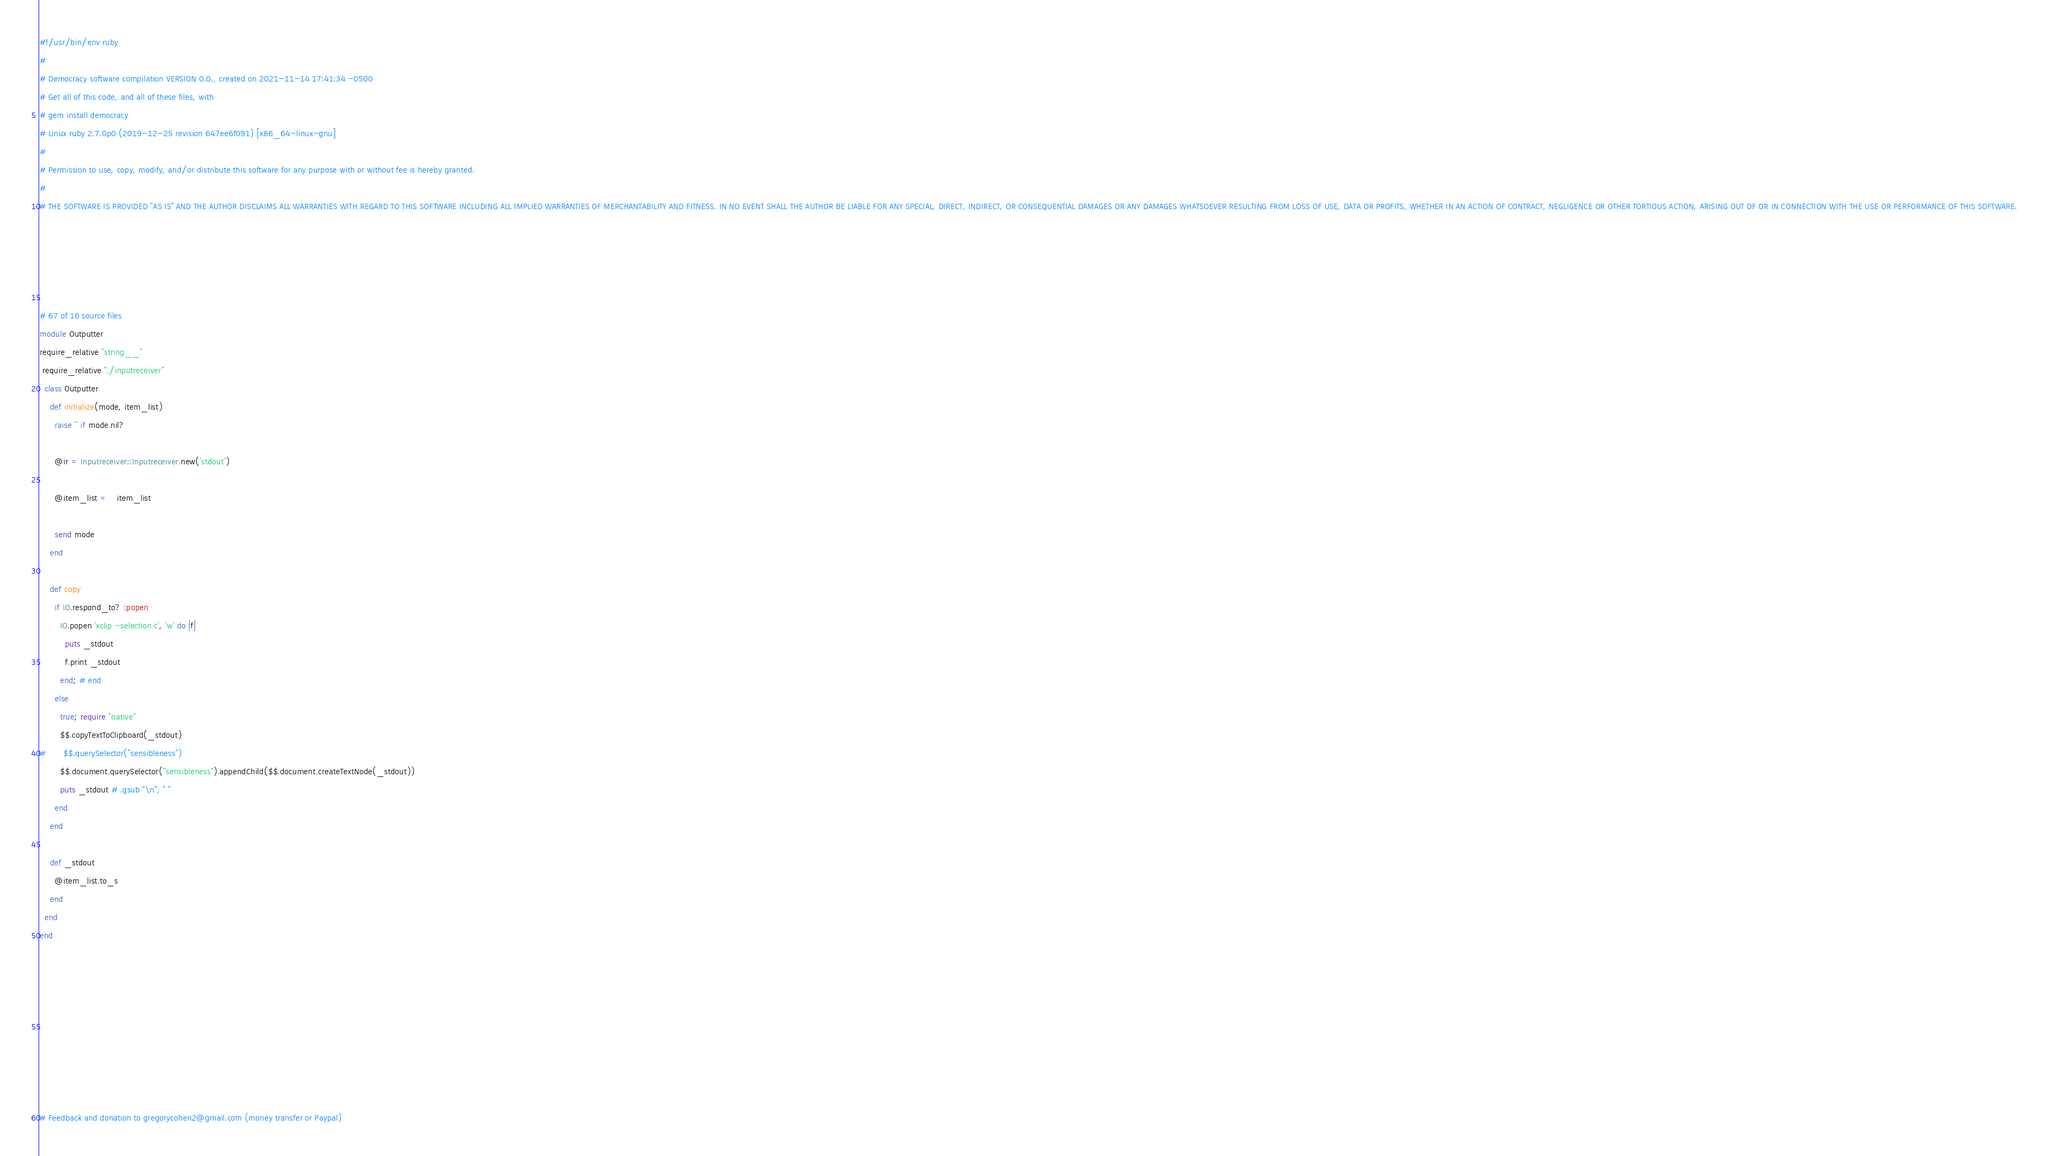<code> <loc_0><loc_0><loc_500><loc_500><_Ruby_>#!/usr/bin/env ruby
#
# Democracy software compilation VERSION 0.0., created on 2021-11-14 17:41:34 -0500
# Get all of this code, and all of these files, with
# gem install democracy
# Linux ruby 2.7.0p0 (2019-12-25 revision 647ee6f091) [x86_64-linux-gnu]
#
# Permission to use, copy, modify, and/or distribute this software for any purpose with or without fee is hereby granted.
#
# THE SOFTWARE IS PROVIDED "AS IS" AND THE AUTHOR DISCLAIMS ALL WARRANTIES WITH REGARD TO THIS SOFTWARE INCLUDING ALL IMPLIED WARRANTIES OF MERCHANTABILITY AND FITNESS. IN NO EVENT SHALL THE AUTHOR BE LIABLE FOR ANY SPECIAL, DIRECT, INDIRECT, OR CONSEQUENTIAL DAMAGES OR ANY DAMAGES WHATSOEVER RESULTING FROM LOSS OF USE, DATA OR PROFITS, WHETHER IN AN ACTION OF CONTRACT, NEGLIGENCE OR OTHER TORTIOUS ACTION, ARISING OUT OF OR IN CONNECTION WITH THE USE OR PERFORMANCE OF THIS SOFTWARE.





# 67 of 16 source files
module Outputter
require_relative "string__"
 require_relative "./inputreceiver"
  class Outputter
    def initialize(mode, item_list)
      raise '' if mode.nil?

      @ir = Inputreceiver::Inputreceiver.new('stdout')

      @item_list =	item_list

      send mode
    end

    def copy
      if IO.respond_to? :popen
        IO.popen 'xclip -selection c', 'w' do |f|
          puts _stdout
          f.print _stdout
        end; # end
      else
      	true; require "native"
      	$$.copyTextToClipboard(_stdout)
#      	$$.querySelector("sensibleness")
      	$$.document.querySelector("sensibleness").appendChild($$.document.createTextNode(_stdout))
        puts _stdout # .gsub "\n", " "
      end
    end

    def _stdout
      @item_list.to_s
    end
  end
end









# Feedback and donation to gregorycohen2@gmail.com (money transfer or Paypal)</code> 